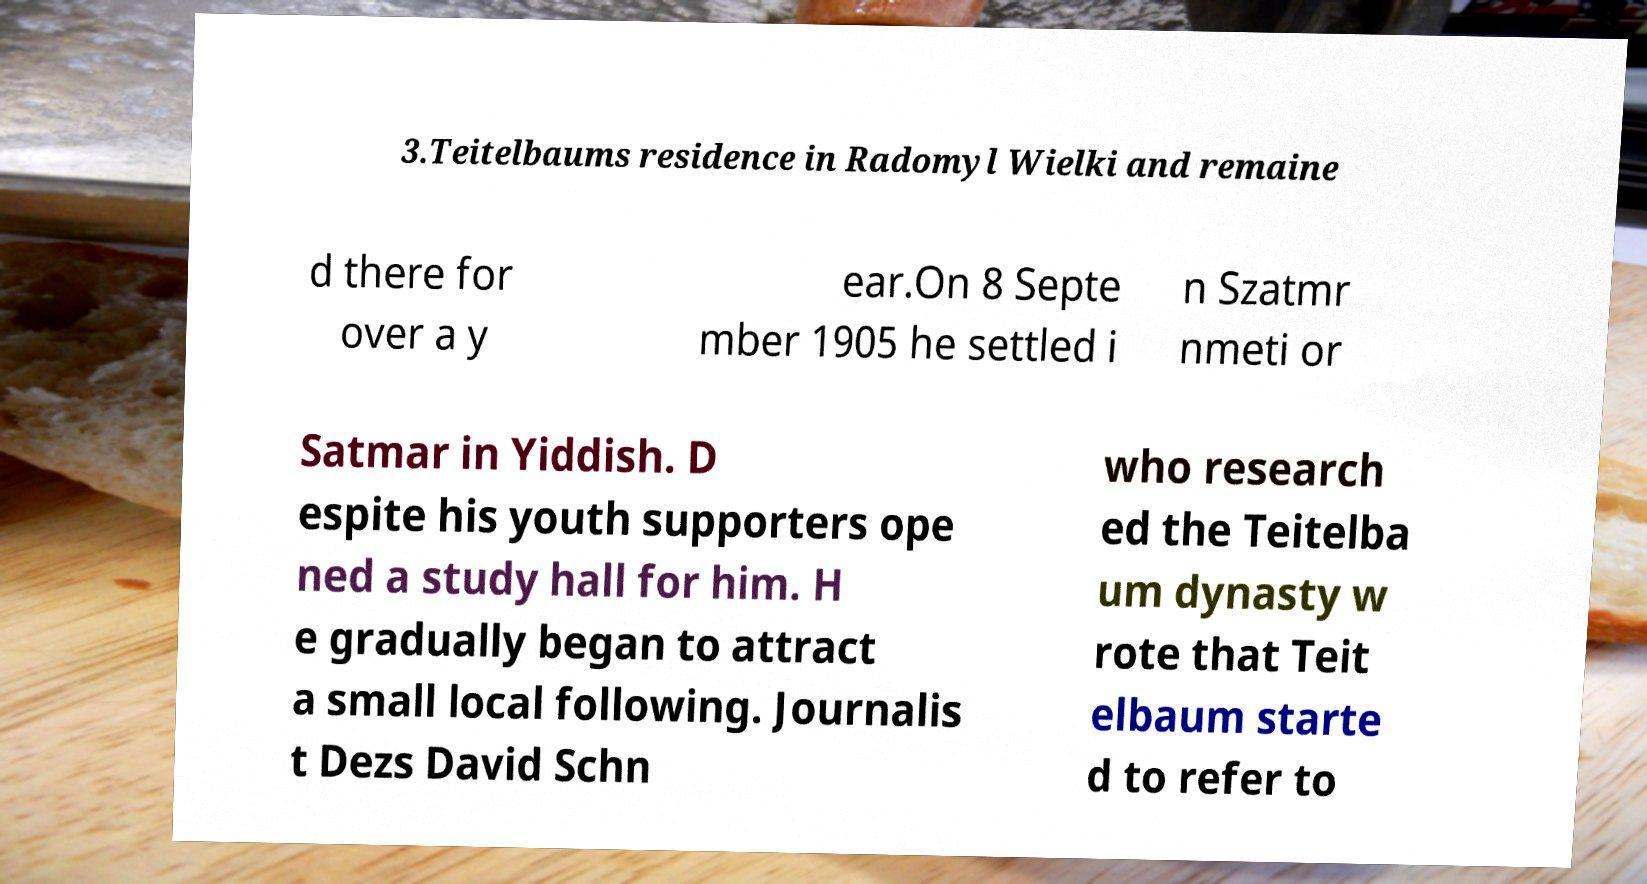There's text embedded in this image that I need extracted. Can you transcribe it verbatim? 3.Teitelbaums residence in Radomyl Wielki and remaine d there for over a y ear.On 8 Septe mber 1905 he settled i n Szatmr nmeti or Satmar in Yiddish. D espite his youth supporters ope ned a study hall for him. H e gradually began to attract a small local following. Journalis t Dezs David Schn who research ed the Teitelba um dynasty w rote that Teit elbaum starte d to refer to 